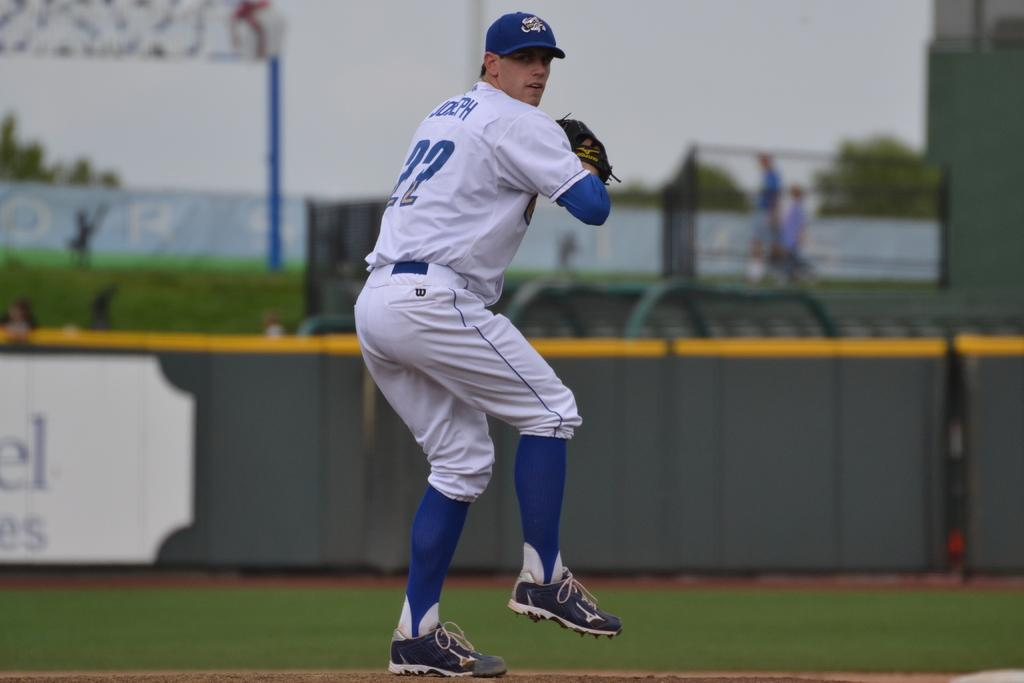What is the man in the image wearing on his head? The man is wearing a cap. What type of clothing is the man wearing on his hands? The man is wearing gloves. What type of footwear is the man wearing? The man is wearing shoes. What is the man standing on in the image? The man is standing on the ground. What can be seen in the background of the image? There is grass, fences, plants, a wall, two people, and some objects in the background of the image. How many mittens is the man wearing in the image? The man is not wearing mittens in the image; he is wearing gloves. What is the man doing to crush the plants in the background of the image? The man is not shown crushing any plants in the image; he is simply standing on the ground. How many legs does the man have in the image? The man has two legs in the image, as is typical for humans. 